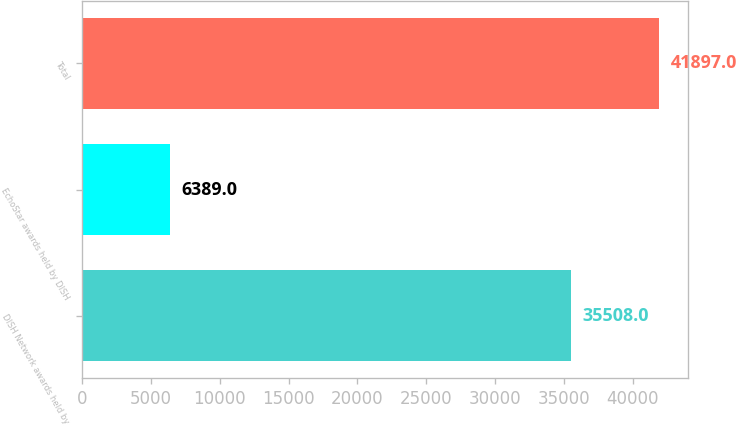<chart> <loc_0><loc_0><loc_500><loc_500><bar_chart><fcel>DISH Network awards held by<fcel>EchoStar awards held by DISH<fcel>Total<nl><fcel>35508<fcel>6389<fcel>41897<nl></chart> 